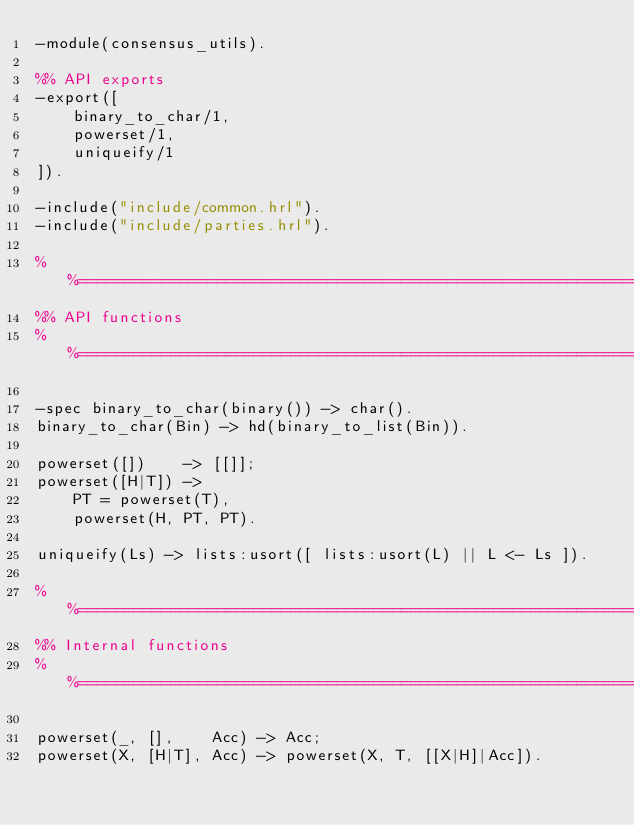Convert code to text. <code><loc_0><loc_0><loc_500><loc_500><_Erlang_>-module(consensus_utils).

%% API exports
-export([
    binary_to_char/1,
    powerset/1,
    uniqueify/1
]).

-include("include/common.hrl").
-include("include/parties.hrl").

%%====================================================================
%% API functions
%%====================================================================

-spec binary_to_char(binary()) -> char().
binary_to_char(Bin) -> hd(binary_to_list(Bin)).

powerset([])    -> [[]];
powerset([H|T]) ->
    PT = powerset(T),
    powerset(H, PT, PT).

uniqueify(Ls) -> lists:usort([ lists:usort(L) || L <- Ls ]).

%%====================================================================
%% Internal functions
%%====================================================================

powerset(_, [],    Acc) -> Acc;
powerset(X, [H|T], Acc) -> powerset(X, T, [[X|H]|Acc]).

</code> 